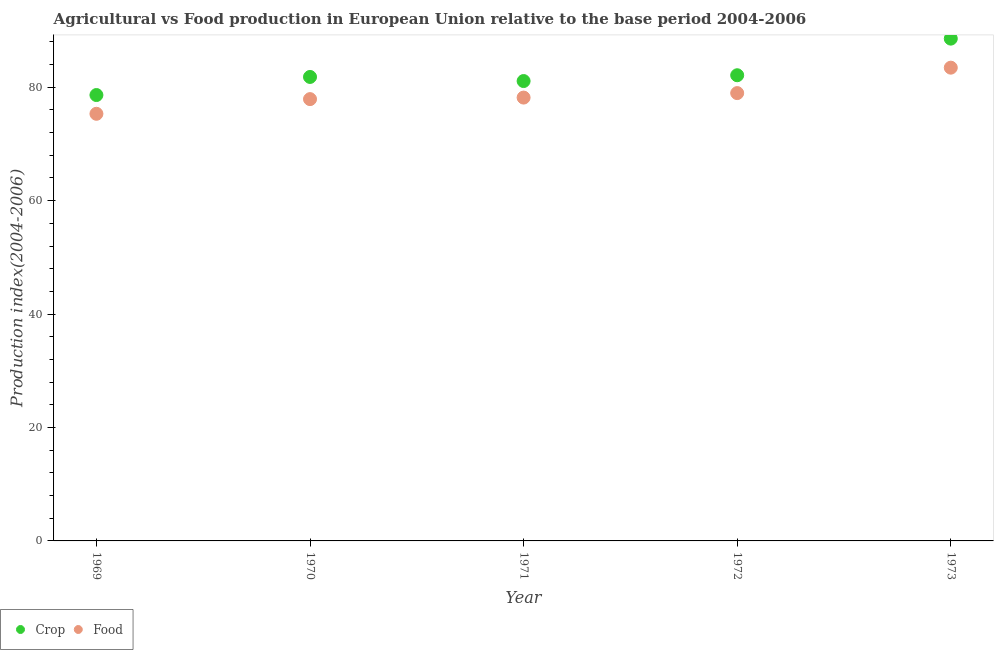What is the food production index in 1973?
Keep it short and to the point. 83.45. Across all years, what is the maximum food production index?
Provide a succinct answer. 83.45. Across all years, what is the minimum food production index?
Offer a very short reply. 75.32. In which year was the crop production index maximum?
Ensure brevity in your answer.  1973. In which year was the crop production index minimum?
Your answer should be compact. 1969. What is the total food production index in the graph?
Make the answer very short. 393.81. What is the difference between the food production index in 1969 and that in 1973?
Offer a very short reply. -8.13. What is the difference between the crop production index in 1970 and the food production index in 1971?
Your response must be concise. 3.64. What is the average food production index per year?
Keep it short and to the point. 78.76. In the year 1973, what is the difference between the food production index and crop production index?
Make the answer very short. -5.12. In how many years, is the food production index greater than 4?
Offer a terse response. 5. What is the ratio of the crop production index in 1971 to that in 1973?
Offer a very short reply. 0.92. Is the food production index in 1969 less than that in 1973?
Offer a very short reply. Yes. Is the difference between the food production index in 1971 and 1973 greater than the difference between the crop production index in 1971 and 1973?
Your answer should be compact. Yes. What is the difference between the highest and the second highest food production index?
Offer a terse response. 4.48. What is the difference between the highest and the lowest food production index?
Your answer should be compact. 8.13. Does the food production index monotonically increase over the years?
Your answer should be very brief. Yes. Is the food production index strictly greater than the crop production index over the years?
Your answer should be very brief. No. Is the food production index strictly less than the crop production index over the years?
Provide a short and direct response. Yes. How many dotlines are there?
Offer a terse response. 2. Does the graph contain any zero values?
Offer a terse response. No. Does the graph contain grids?
Your answer should be compact. No. Where does the legend appear in the graph?
Provide a short and direct response. Bottom left. How are the legend labels stacked?
Make the answer very short. Horizontal. What is the title of the graph?
Offer a very short reply. Agricultural vs Food production in European Union relative to the base period 2004-2006. What is the label or title of the X-axis?
Your answer should be very brief. Year. What is the label or title of the Y-axis?
Make the answer very short. Production index(2004-2006). What is the Production index(2004-2006) of Crop in 1969?
Offer a terse response. 78.62. What is the Production index(2004-2006) of Food in 1969?
Provide a short and direct response. 75.32. What is the Production index(2004-2006) in Crop in 1970?
Ensure brevity in your answer.  81.81. What is the Production index(2004-2006) of Food in 1970?
Your answer should be very brief. 77.9. What is the Production index(2004-2006) of Crop in 1971?
Ensure brevity in your answer.  81.09. What is the Production index(2004-2006) in Food in 1971?
Give a very brief answer. 78.17. What is the Production index(2004-2006) in Crop in 1972?
Give a very brief answer. 82.11. What is the Production index(2004-2006) in Food in 1972?
Offer a terse response. 78.97. What is the Production index(2004-2006) of Crop in 1973?
Provide a short and direct response. 88.57. What is the Production index(2004-2006) in Food in 1973?
Offer a terse response. 83.45. Across all years, what is the maximum Production index(2004-2006) of Crop?
Offer a very short reply. 88.57. Across all years, what is the maximum Production index(2004-2006) in Food?
Provide a succinct answer. 83.45. Across all years, what is the minimum Production index(2004-2006) in Crop?
Your response must be concise. 78.62. Across all years, what is the minimum Production index(2004-2006) in Food?
Make the answer very short. 75.32. What is the total Production index(2004-2006) of Crop in the graph?
Your answer should be very brief. 412.2. What is the total Production index(2004-2006) of Food in the graph?
Offer a very short reply. 393.81. What is the difference between the Production index(2004-2006) in Crop in 1969 and that in 1970?
Provide a short and direct response. -3.19. What is the difference between the Production index(2004-2006) in Food in 1969 and that in 1970?
Make the answer very short. -2.59. What is the difference between the Production index(2004-2006) of Crop in 1969 and that in 1971?
Your answer should be compact. -2.47. What is the difference between the Production index(2004-2006) of Food in 1969 and that in 1971?
Your response must be concise. -2.86. What is the difference between the Production index(2004-2006) in Crop in 1969 and that in 1972?
Provide a short and direct response. -3.49. What is the difference between the Production index(2004-2006) of Food in 1969 and that in 1972?
Your answer should be compact. -3.65. What is the difference between the Production index(2004-2006) of Crop in 1969 and that in 1973?
Ensure brevity in your answer.  -9.95. What is the difference between the Production index(2004-2006) in Food in 1969 and that in 1973?
Provide a short and direct response. -8.13. What is the difference between the Production index(2004-2006) of Crop in 1970 and that in 1971?
Ensure brevity in your answer.  0.72. What is the difference between the Production index(2004-2006) in Food in 1970 and that in 1971?
Offer a very short reply. -0.27. What is the difference between the Production index(2004-2006) in Crop in 1970 and that in 1972?
Offer a very short reply. -0.3. What is the difference between the Production index(2004-2006) of Food in 1970 and that in 1972?
Keep it short and to the point. -1.06. What is the difference between the Production index(2004-2006) of Crop in 1970 and that in 1973?
Your answer should be compact. -6.76. What is the difference between the Production index(2004-2006) of Food in 1970 and that in 1973?
Your response must be concise. -5.55. What is the difference between the Production index(2004-2006) of Crop in 1971 and that in 1972?
Your response must be concise. -1.02. What is the difference between the Production index(2004-2006) of Food in 1971 and that in 1972?
Ensure brevity in your answer.  -0.79. What is the difference between the Production index(2004-2006) in Crop in 1971 and that in 1973?
Offer a terse response. -7.48. What is the difference between the Production index(2004-2006) in Food in 1971 and that in 1973?
Make the answer very short. -5.28. What is the difference between the Production index(2004-2006) in Crop in 1972 and that in 1973?
Provide a succinct answer. -6.46. What is the difference between the Production index(2004-2006) in Food in 1972 and that in 1973?
Your response must be concise. -4.48. What is the difference between the Production index(2004-2006) of Crop in 1969 and the Production index(2004-2006) of Food in 1970?
Your answer should be compact. 0.72. What is the difference between the Production index(2004-2006) of Crop in 1969 and the Production index(2004-2006) of Food in 1971?
Ensure brevity in your answer.  0.45. What is the difference between the Production index(2004-2006) of Crop in 1969 and the Production index(2004-2006) of Food in 1972?
Ensure brevity in your answer.  -0.34. What is the difference between the Production index(2004-2006) in Crop in 1969 and the Production index(2004-2006) in Food in 1973?
Give a very brief answer. -4.83. What is the difference between the Production index(2004-2006) in Crop in 1970 and the Production index(2004-2006) in Food in 1971?
Your answer should be very brief. 3.64. What is the difference between the Production index(2004-2006) of Crop in 1970 and the Production index(2004-2006) of Food in 1972?
Ensure brevity in your answer.  2.85. What is the difference between the Production index(2004-2006) in Crop in 1970 and the Production index(2004-2006) in Food in 1973?
Keep it short and to the point. -1.64. What is the difference between the Production index(2004-2006) in Crop in 1971 and the Production index(2004-2006) in Food in 1972?
Provide a succinct answer. 2.12. What is the difference between the Production index(2004-2006) of Crop in 1971 and the Production index(2004-2006) of Food in 1973?
Ensure brevity in your answer.  -2.36. What is the difference between the Production index(2004-2006) of Crop in 1972 and the Production index(2004-2006) of Food in 1973?
Offer a terse response. -1.34. What is the average Production index(2004-2006) in Crop per year?
Provide a short and direct response. 82.44. What is the average Production index(2004-2006) of Food per year?
Provide a short and direct response. 78.76. In the year 1969, what is the difference between the Production index(2004-2006) in Crop and Production index(2004-2006) in Food?
Offer a terse response. 3.31. In the year 1970, what is the difference between the Production index(2004-2006) in Crop and Production index(2004-2006) in Food?
Give a very brief answer. 3.91. In the year 1971, what is the difference between the Production index(2004-2006) of Crop and Production index(2004-2006) of Food?
Your answer should be compact. 2.92. In the year 1972, what is the difference between the Production index(2004-2006) of Crop and Production index(2004-2006) of Food?
Provide a succinct answer. 3.15. In the year 1973, what is the difference between the Production index(2004-2006) in Crop and Production index(2004-2006) in Food?
Provide a short and direct response. 5.12. What is the ratio of the Production index(2004-2006) of Crop in 1969 to that in 1970?
Your answer should be very brief. 0.96. What is the ratio of the Production index(2004-2006) of Food in 1969 to that in 1970?
Your answer should be very brief. 0.97. What is the ratio of the Production index(2004-2006) of Crop in 1969 to that in 1971?
Give a very brief answer. 0.97. What is the ratio of the Production index(2004-2006) of Food in 1969 to that in 1971?
Your answer should be compact. 0.96. What is the ratio of the Production index(2004-2006) of Crop in 1969 to that in 1972?
Make the answer very short. 0.96. What is the ratio of the Production index(2004-2006) of Food in 1969 to that in 1972?
Offer a very short reply. 0.95. What is the ratio of the Production index(2004-2006) in Crop in 1969 to that in 1973?
Provide a succinct answer. 0.89. What is the ratio of the Production index(2004-2006) of Food in 1969 to that in 1973?
Offer a very short reply. 0.9. What is the ratio of the Production index(2004-2006) in Crop in 1970 to that in 1971?
Your answer should be very brief. 1.01. What is the ratio of the Production index(2004-2006) of Food in 1970 to that in 1971?
Ensure brevity in your answer.  1. What is the ratio of the Production index(2004-2006) in Crop in 1970 to that in 1972?
Ensure brevity in your answer.  1. What is the ratio of the Production index(2004-2006) of Food in 1970 to that in 1972?
Keep it short and to the point. 0.99. What is the ratio of the Production index(2004-2006) in Crop in 1970 to that in 1973?
Your answer should be compact. 0.92. What is the ratio of the Production index(2004-2006) of Food in 1970 to that in 1973?
Ensure brevity in your answer.  0.93. What is the ratio of the Production index(2004-2006) of Crop in 1971 to that in 1972?
Ensure brevity in your answer.  0.99. What is the ratio of the Production index(2004-2006) in Crop in 1971 to that in 1973?
Keep it short and to the point. 0.92. What is the ratio of the Production index(2004-2006) in Food in 1971 to that in 1973?
Offer a terse response. 0.94. What is the ratio of the Production index(2004-2006) in Crop in 1972 to that in 1973?
Your response must be concise. 0.93. What is the ratio of the Production index(2004-2006) of Food in 1972 to that in 1973?
Your answer should be very brief. 0.95. What is the difference between the highest and the second highest Production index(2004-2006) of Crop?
Ensure brevity in your answer.  6.46. What is the difference between the highest and the second highest Production index(2004-2006) in Food?
Offer a terse response. 4.48. What is the difference between the highest and the lowest Production index(2004-2006) in Crop?
Your answer should be compact. 9.95. What is the difference between the highest and the lowest Production index(2004-2006) in Food?
Provide a short and direct response. 8.13. 